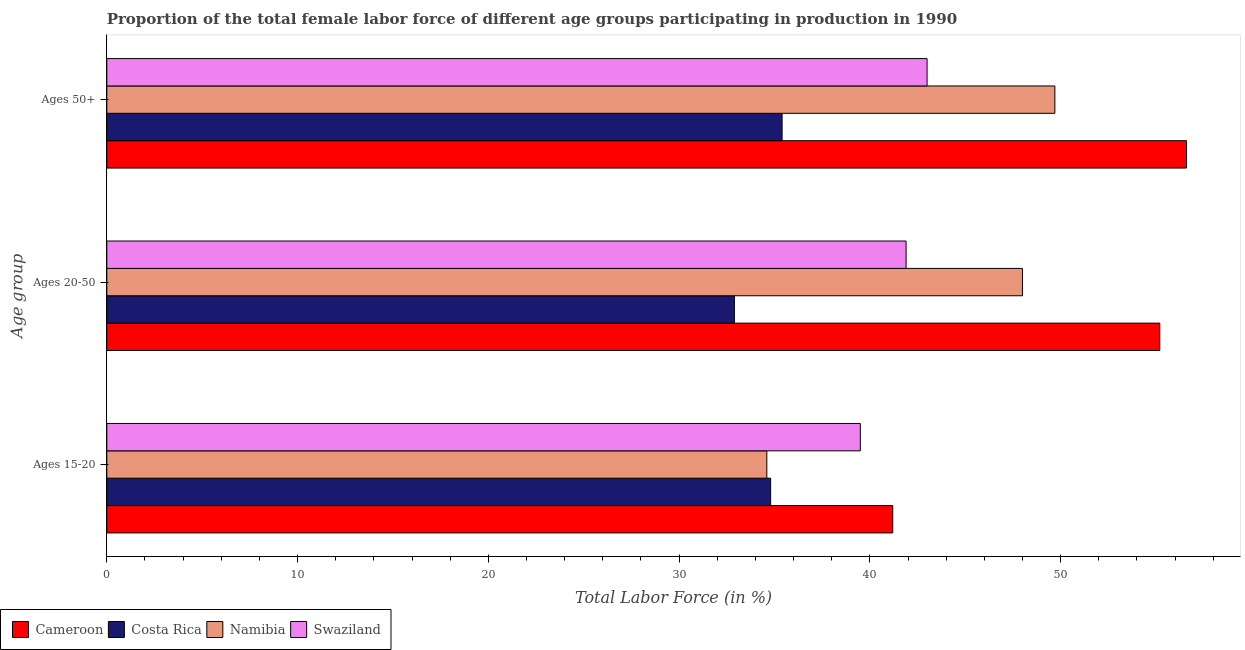How many groups of bars are there?
Keep it short and to the point. 3. Are the number of bars on each tick of the Y-axis equal?
Your answer should be compact. Yes. What is the label of the 3rd group of bars from the top?
Give a very brief answer. Ages 15-20. What is the percentage of female labor force within the age group 15-20 in Namibia?
Ensure brevity in your answer.  34.6. Across all countries, what is the maximum percentage of female labor force above age 50?
Make the answer very short. 56.6. Across all countries, what is the minimum percentage of female labor force above age 50?
Your answer should be very brief. 35.4. In which country was the percentage of female labor force above age 50 maximum?
Your answer should be very brief. Cameroon. In which country was the percentage of female labor force within the age group 20-50 minimum?
Offer a very short reply. Costa Rica. What is the total percentage of female labor force within the age group 20-50 in the graph?
Keep it short and to the point. 178. What is the difference between the percentage of female labor force above age 50 in Namibia and that in Costa Rica?
Make the answer very short. 14.3. What is the difference between the percentage of female labor force within the age group 20-50 in Cameroon and the percentage of female labor force within the age group 15-20 in Namibia?
Ensure brevity in your answer.  20.6. What is the average percentage of female labor force above age 50 per country?
Make the answer very short. 46.18. What is the difference between the percentage of female labor force above age 50 and percentage of female labor force within the age group 15-20 in Cameroon?
Offer a terse response. 15.4. In how many countries, is the percentage of female labor force above age 50 greater than 20 %?
Your answer should be very brief. 4. What is the ratio of the percentage of female labor force within the age group 15-20 in Namibia to that in Swaziland?
Your answer should be compact. 0.88. Is the percentage of female labor force within the age group 20-50 in Cameroon less than that in Swaziland?
Provide a succinct answer. No. Is the difference between the percentage of female labor force above age 50 in Cameroon and Costa Rica greater than the difference between the percentage of female labor force within the age group 15-20 in Cameroon and Costa Rica?
Your answer should be very brief. Yes. What is the difference between the highest and the second highest percentage of female labor force above age 50?
Your answer should be very brief. 6.9. What is the difference between the highest and the lowest percentage of female labor force above age 50?
Offer a terse response. 21.2. In how many countries, is the percentage of female labor force within the age group 20-50 greater than the average percentage of female labor force within the age group 20-50 taken over all countries?
Your answer should be very brief. 2. Is the sum of the percentage of female labor force within the age group 15-20 in Swaziland and Namibia greater than the maximum percentage of female labor force within the age group 20-50 across all countries?
Your response must be concise. Yes. What does the 4th bar from the top in Ages 50+ represents?
Your answer should be compact. Cameroon. What does the 2nd bar from the bottom in Ages 20-50 represents?
Make the answer very short. Costa Rica. Is it the case that in every country, the sum of the percentage of female labor force within the age group 15-20 and percentage of female labor force within the age group 20-50 is greater than the percentage of female labor force above age 50?
Offer a very short reply. Yes. Are all the bars in the graph horizontal?
Your answer should be compact. Yes. How many countries are there in the graph?
Your answer should be compact. 4. What is the difference between two consecutive major ticks on the X-axis?
Keep it short and to the point. 10. Are the values on the major ticks of X-axis written in scientific E-notation?
Offer a very short reply. No. Does the graph contain any zero values?
Provide a short and direct response. No. How are the legend labels stacked?
Provide a succinct answer. Horizontal. What is the title of the graph?
Make the answer very short. Proportion of the total female labor force of different age groups participating in production in 1990. What is the label or title of the X-axis?
Provide a succinct answer. Total Labor Force (in %). What is the label or title of the Y-axis?
Keep it short and to the point. Age group. What is the Total Labor Force (in %) of Cameroon in Ages 15-20?
Make the answer very short. 41.2. What is the Total Labor Force (in %) in Costa Rica in Ages 15-20?
Offer a very short reply. 34.8. What is the Total Labor Force (in %) in Namibia in Ages 15-20?
Offer a very short reply. 34.6. What is the Total Labor Force (in %) in Swaziland in Ages 15-20?
Your answer should be very brief. 39.5. What is the Total Labor Force (in %) in Cameroon in Ages 20-50?
Give a very brief answer. 55.2. What is the Total Labor Force (in %) in Costa Rica in Ages 20-50?
Offer a terse response. 32.9. What is the Total Labor Force (in %) of Namibia in Ages 20-50?
Keep it short and to the point. 48. What is the Total Labor Force (in %) in Swaziland in Ages 20-50?
Make the answer very short. 41.9. What is the Total Labor Force (in %) of Cameroon in Ages 50+?
Your answer should be very brief. 56.6. What is the Total Labor Force (in %) of Costa Rica in Ages 50+?
Provide a short and direct response. 35.4. What is the Total Labor Force (in %) of Namibia in Ages 50+?
Your answer should be compact. 49.7. Across all Age group, what is the maximum Total Labor Force (in %) of Cameroon?
Offer a terse response. 56.6. Across all Age group, what is the maximum Total Labor Force (in %) of Costa Rica?
Make the answer very short. 35.4. Across all Age group, what is the maximum Total Labor Force (in %) of Namibia?
Your response must be concise. 49.7. Across all Age group, what is the minimum Total Labor Force (in %) in Cameroon?
Make the answer very short. 41.2. Across all Age group, what is the minimum Total Labor Force (in %) in Costa Rica?
Provide a succinct answer. 32.9. Across all Age group, what is the minimum Total Labor Force (in %) in Namibia?
Offer a terse response. 34.6. Across all Age group, what is the minimum Total Labor Force (in %) in Swaziland?
Your response must be concise. 39.5. What is the total Total Labor Force (in %) of Cameroon in the graph?
Your response must be concise. 153. What is the total Total Labor Force (in %) of Costa Rica in the graph?
Give a very brief answer. 103.1. What is the total Total Labor Force (in %) of Namibia in the graph?
Give a very brief answer. 132.3. What is the total Total Labor Force (in %) in Swaziland in the graph?
Provide a succinct answer. 124.4. What is the difference between the Total Labor Force (in %) in Cameroon in Ages 15-20 and that in Ages 50+?
Keep it short and to the point. -15.4. What is the difference between the Total Labor Force (in %) in Namibia in Ages 15-20 and that in Ages 50+?
Offer a very short reply. -15.1. What is the difference between the Total Labor Force (in %) in Namibia in Ages 20-50 and that in Ages 50+?
Your response must be concise. -1.7. What is the difference between the Total Labor Force (in %) of Cameroon in Ages 15-20 and the Total Labor Force (in %) of Namibia in Ages 20-50?
Ensure brevity in your answer.  -6.8. What is the difference between the Total Labor Force (in %) in Costa Rica in Ages 15-20 and the Total Labor Force (in %) in Namibia in Ages 20-50?
Your response must be concise. -13.2. What is the difference between the Total Labor Force (in %) of Costa Rica in Ages 15-20 and the Total Labor Force (in %) of Swaziland in Ages 20-50?
Offer a terse response. -7.1. What is the difference between the Total Labor Force (in %) in Cameroon in Ages 15-20 and the Total Labor Force (in %) in Swaziland in Ages 50+?
Keep it short and to the point. -1.8. What is the difference between the Total Labor Force (in %) in Costa Rica in Ages 15-20 and the Total Labor Force (in %) in Namibia in Ages 50+?
Provide a short and direct response. -14.9. What is the difference between the Total Labor Force (in %) in Namibia in Ages 15-20 and the Total Labor Force (in %) in Swaziland in Ages 50+?
Offer a terse response. -8.4. What is the difference between the Total Labor Force (in %) of Cameroon in Ages 20-50 and the Total Labor Force (in %) of Costa Rica in Ages 50+?
Give a very brief answer. 19.8. What is the difference between the Total Labor Force (in %) of Costa Rica in Ages 20-50 and the Total Labor Force (in %) of Namibia in Ages 50+?
Offer a very short reply. -16.8. What is the difference between the Total Labor Force (in %) of Namibia in Ages 20-50 and the Total Labor Force (in %) of Swaziland in Ages 50+?
Offer a terse response. 5. What is the average Total Labor Force (in %) in Costa Rica per Age group?
Your answer should be very brief. 34.37. What is the average Total Labor Force (in %) of Namibia per Age group?
Your response must be concise. 44.1. What is the average Total Labor Force (in %) in Swaziland per Age group?
Provide a succinct answer. 41.47. What is the difference between the Total Labor Force (in %) of Costa Rica and Total Labor Force (in %) of Namibia in Ages 15-20?
Offer a very short reply. 0.2. What is the difference between the Total Labor Force (in %) in Namibia and Total Labor Force (in %) in Swaziland in Ages 15-20?
Keep it short and to the point. -4.9. What is the difference between the Total Labor Force (in %) in Cameroon and Total Labor Force (in %) in Costa Rica in Ages 20-50?
Make the answer very short. 22.3. What is the difference between the Total Labor Force (in %) of Cameroon and Total Labor Force (in %) of Swaziland in Ages 20-50?
Make the answer very short. 13.3. What is the difference between the Total Labor Force (in %) in Costa Rica and Total Labor Force (in %) in Namibia in Ages 20-50?
Your answer should be very brief. -15.1. What is the difference between the Total Labor Force (in %) of Cameroon and Total Labor Force (in %) of Costa Rica in Ages 50+?
Ensure brevity in your answer.  21.2. What is the difference between the Total Labor Force (in %) of Cameroon and Total Labor Force (in %) of Swaziland in Ages 50+?
Give a very brief answer. 13.6. What is the difference between the Total Labor Force (in %) in Costa Rica and Total Labor Force (in %) in Namibia in Ages 50+?
Give a very brief answer. -14.3. What is the difference between the Total Labor Force (in %) of Costa Rica and Total Labor Force (in %) of Swaziland in Ages 50+?
Your answer should be compact. -7.6. What is the ratio of the Total Labor Force (in %) in Cameroon in Ages 15-20 to that in Ages 20-50?
Provide a short and direct response. 0.75. What is the ratio of the Total Labor Force (in %) of Costa Rica in Ages 15-20 to that in Ages 20-50?
Your answer should be very brief. 1.06. What is the ratio of the Total Labor Force (in %) in Namibia in Ages 15-20 to that in Ages 20-50?
Your answer should be compact. 0.72. What is the ratio of the Total Labor Force (in %) in Swaziland in Ages 15-20 to that in Ages 20-50?
Ensure brevity in your answer.  0.94. What is the ratio of the Total Labor Force (in %) in Cameroon in Ages 15-20 to that in Ages 50+?
Provide a succinct answer. 0.73. What is the ratio of the Total Labor Force (in %) of Costa Rica in Ages 15-20 to that in Ages 50+?
Make the answer very short. 0.98. What is the ratio of the Total Labor Force (in %) of Namibia in Ages 15-20 to that in Ages 50+?
Provide a short and direct response. 0.7. What is the ratio of the Total Labor Force (in %) of Swaziland in Ages 15-20 to that in Ages 50+?
Keep it short and to the point. 0.92. What is the ratio of the Total Labor Force (in %) in Cameroon in Ages 20-50 to that in Ages 50+?
Your response must be concise. 0.98. What is the ratio of the Total Labor Force (in %) in Costa Rica in Ages 20-50 to that in Ages 50+?
Your answer should be compact. 0.93. What is the ratio of the Total Labor Force (in %) of Namibia in Ages 20-50 to that in Ages 50+?
Keep it short and to the point. 0.97. What is the ratio of the Total Labor Force (in %) in Swaziland in Ages 20-50 to that in Ages 50+?
Make the answer very short. 0.97. What is the difference between the highest and the second highest Total Labor Force (in %) of Cameroon?
Make the answer very short. 1.4. What is the difference between the highest and the second highest Total Labor Force (in %) of Namibia?
Your answer should be very brief. 1.7. What is the difference between the highest and the lowest Total Labor Force (in %) in Costa Rica?
Provide a short and direct response. 2.5. What is the difference between the highest and the lowest Total Labor Force (in %) of Namibia?
Provide a succinct answer. 15.1. What is the difference between the highest and the lowest Total Labor Force (in %) in Swaziland?
Your answer should be compact. 3.5. 